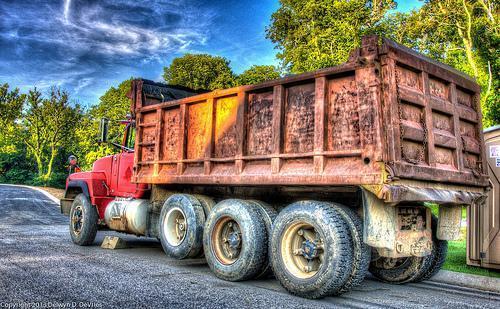How many trucks are there?
Give a very brief answer. 1. 